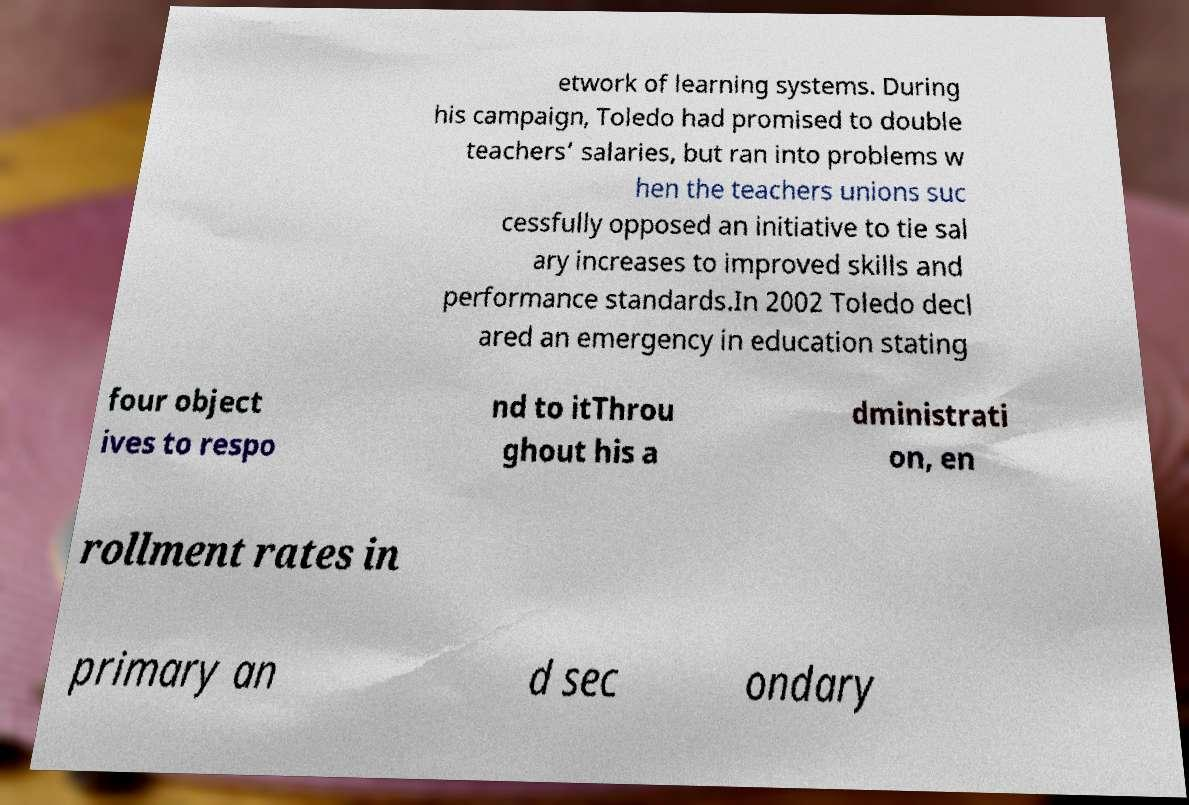Could you assist in decoding the text presented in this image and type it out clearly? etwork of learning systems. During his campaign, Toledo had promised to double teachers’ salaries, but ran into problems w hen the teachers unions suc cessfully opposed an initiative to tie sal ary increases to improved skills and performance standards.In 2002 Toledo decl ared an emergency in education stating four object ives to respo nd to itThrou ghout his a dministrati on, en rollment rates in primary an d sec ondary 